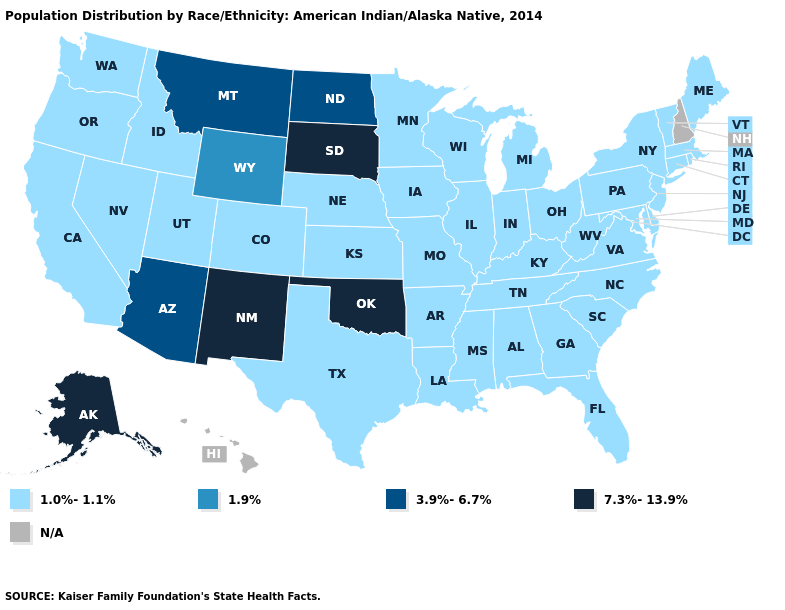What is the value of North Dakota?
Be succinct. 3.9%-6.7%. Does the map have missing data?
Concise answer only. Yes. Name the states that have a value in the range 3.9%-6.7%?
Short answer required. Arizona, Montana, North Dakota. What is the highest value in the USA?
Keep it brief. 7.3%-13.9%. Name the states that have a value in the range 1.9%?
Short answer required. Wyoming. Does North Carolina have the lowest value in the USA?
Be succinct. Yes. Does the first symbol in the legend represent the smallest category?
Be succinct. Yes. What is the value of New York?
Keep it brief. 1.0%-1.1%. What is the highest value in states that border Wyoming?
Short answer required. 7.3%-13.9%. Among the states that border Idaho , which have the lowest value?
Short answer required. Nevada, Oregon, Utah, Washington. Name the states that have a value in the range 7.3%-13.9%?
Keep it brief. Alaska, New Mexico, Oklahoma, South Dakota. Does South Dakota have the highest value in the USA?
Quick response, please. Yes. Does West Virginia have the lowest value in the USA?
Short answer required. Yes. Does Massachusetts have the highest value in the USA?
Give a very brief answer. No. 